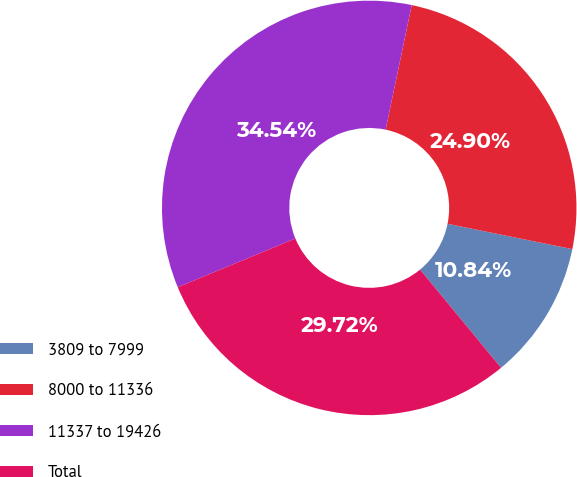Convert chart to OTSL. <chart><loc_0><loc_0><loc_500><loc_500><pie_chart><fcel>3809 to 7999<fcel>8000 to 11336<fcel>11337 to 19426<fcel>Total<nl><fcel>10.84%<fcel>24.9%<fcel>34.54%<fcel>29.72%<nl></chart> 